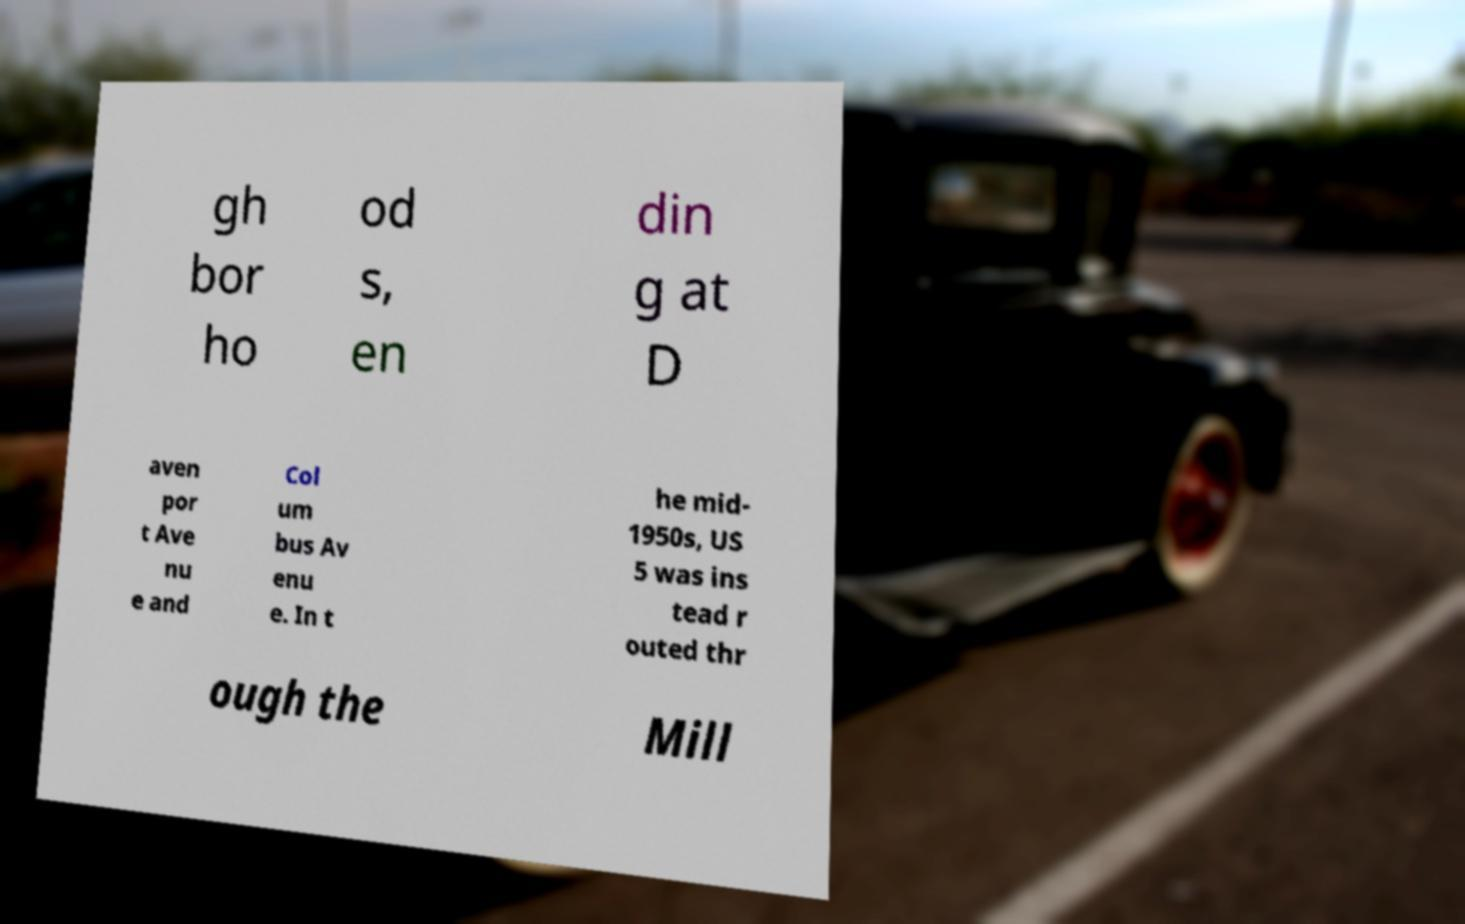For documentation purposes, I need the text within this image transcribed. Could you provide that? gh bor ho od s, en din g at D aven por t Ave nu e and Col um bus Av enu e. In t he mid- 1950s, US 5 was ins tead r outed thr ough the Mill 